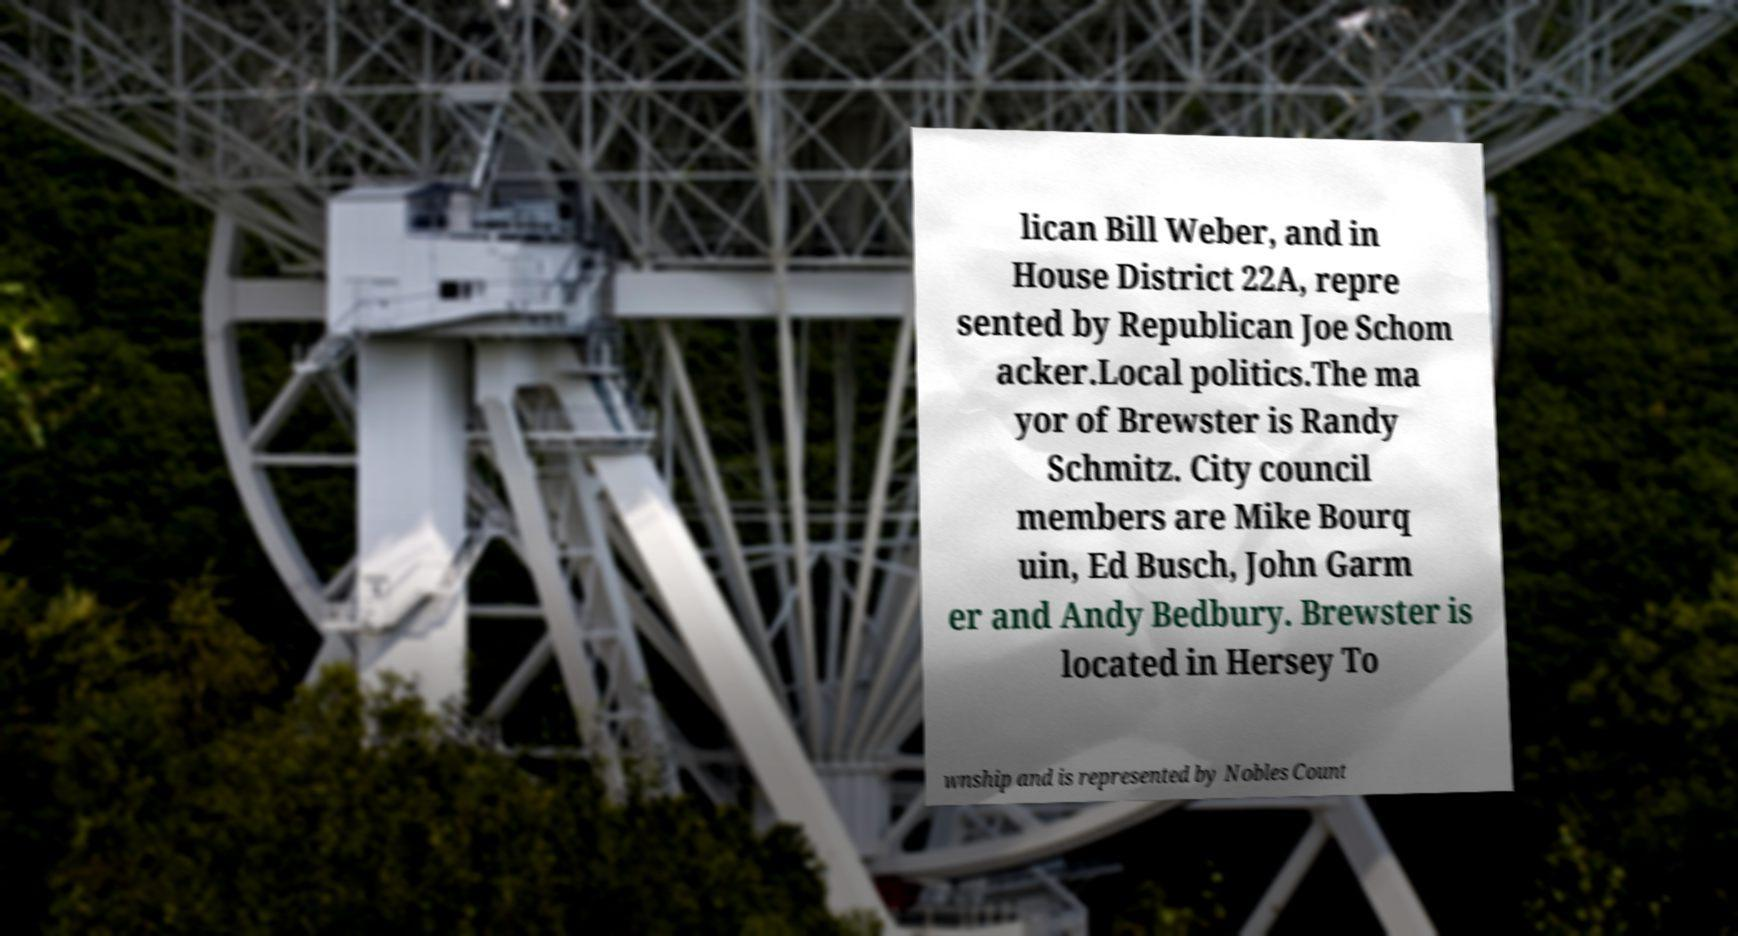Can you read and provide the text displayed in the image?This photo seems to have some interesting text. Can you extract and type it out for me? lican Bill Weber, and in House District 22A, repre sented by Republican Joe Schom acker.Local politics.The ma yor of Brewster is Randy Schmitz. City council members are Mike Bourq uin, Ed Busch, John Garm er and Andy Bedbury. Brewster is located in Hersey To wnship and is represented by Nobles Count 